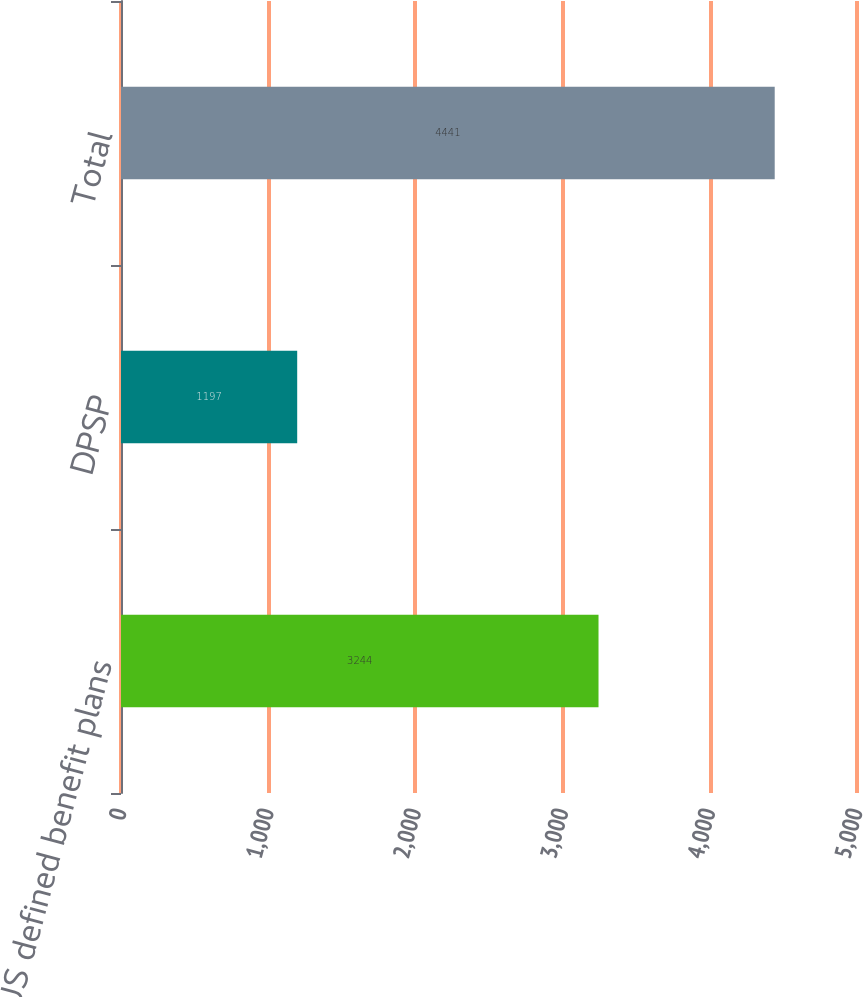Convert chart. <chart><loc_0><loc_0><loc_500><loc_500><bar_chart><fcel>US defined benefit plans<fcel>DPSP<fcel>Total<nl><fcel>3244<fcel>1197<fcel>4441<nl></chart> 